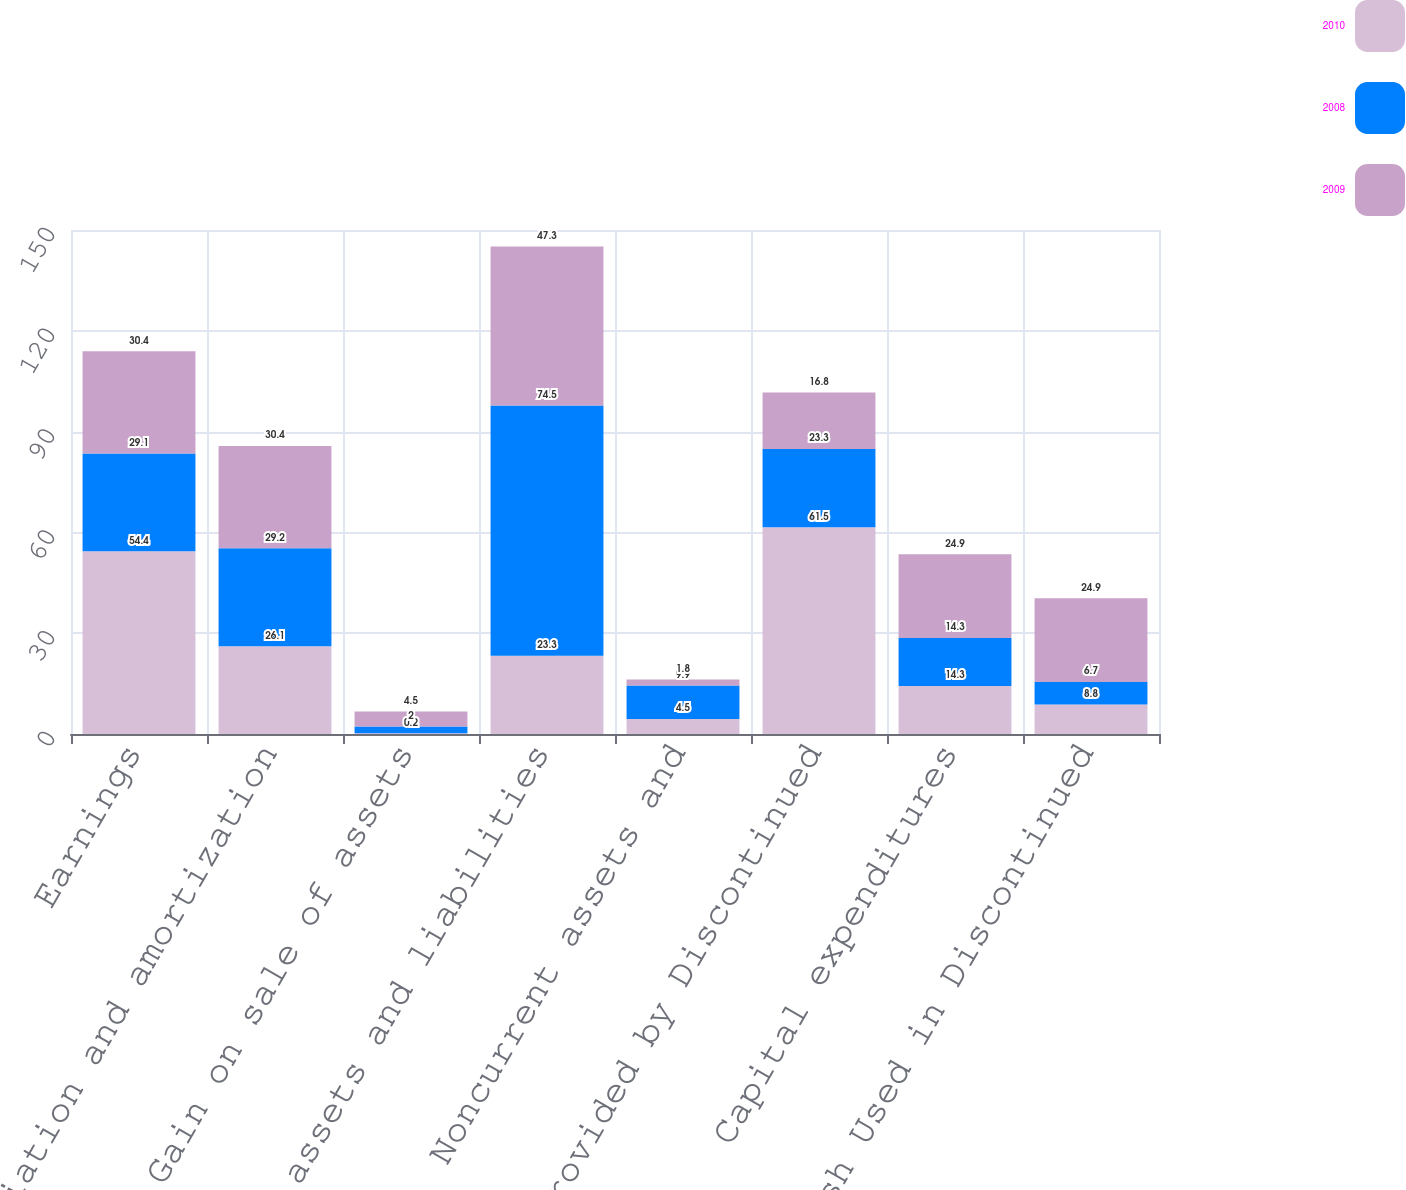Convert chart. <chart><loc_0><loc_0><loc_500><loc_500><stacked_bar_chart><ecel><fcel>Earnings<fcel>Depreciation and amortization<fcel>Gain on sale of assets<fcel>Current assets and liabilities<fcel>Noncurrent assets and<fcel>Cash Provided by Discontinued<fcel>Capital expenditures<fcel>Cash Used in Discontinued<nl><fcel>2010<fcel>54.4<fcel>26.1<fcel>0.2<fcel>23.3<fcel>4.5<fcel>61.5<fcel>14.3<fcel>8.8<nl><fcel>2008<fcel>29.1<fcel>29.2<fcel>2<fcel>74.5<fcel>9.9<fcel>23.3<fcel>14.3<fcel>6.7<nl><fcel>2009<fcel>30.4<fcel>30.4<fcel>4.5<fcel>47.3<fcel>1.8<fcel>16.8<fcel>24.9<fcel>24.9<nl></chart> 